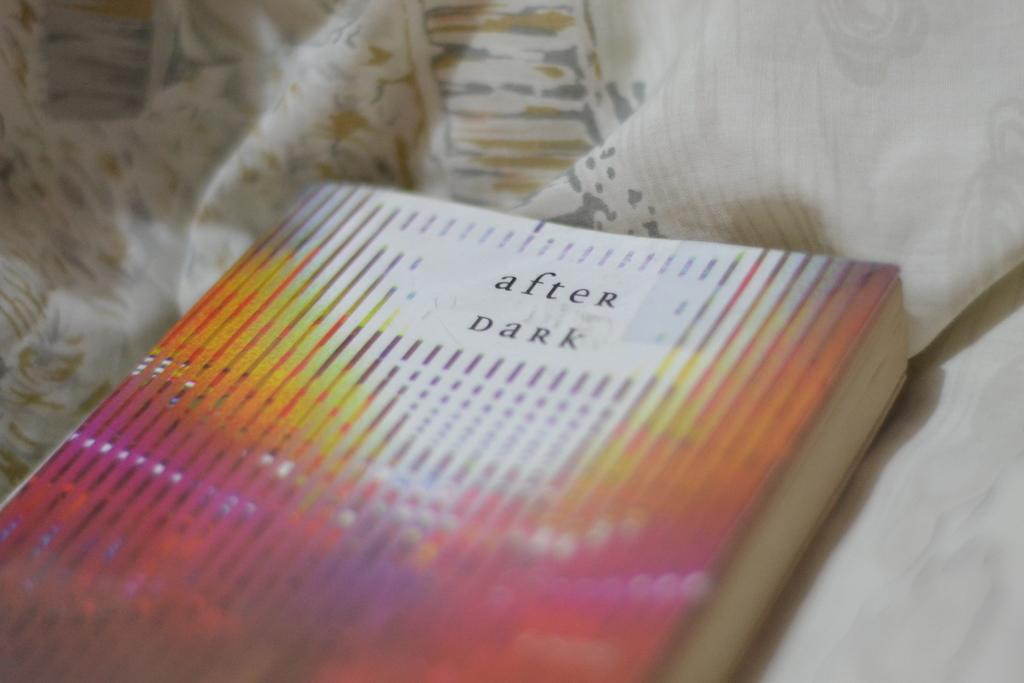<image>
Relay a brief, clear account of the picture shown. The book After Dark is laying on bedsheets. 